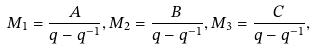Convert formula to latex. <formula><loc_0><loc_0><loc_500><loc_500>M _ { 1 } = \frac { A } { q - q ^ { - 1 } } , M _ { 2 } = \frac { B } { q - q ^ { - 1 } } , M _ { 3 } = \frac { C } { q - q ^ { - 1 } } ,</formula> 